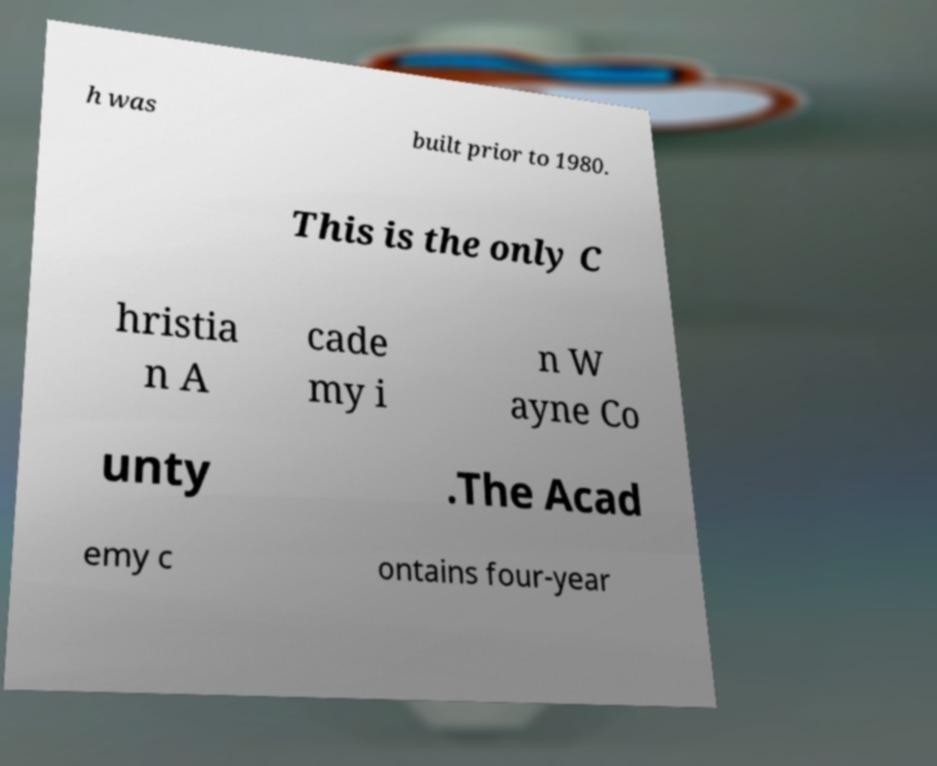Can you read and provide the text displayed in the image?This photo seems to have some interesting text. Can you extract and type it out for me? h was built prior to 1980. This is the only C hristia n A cade my i n W ayne Co unty .The Acad emy c ontains four-year 